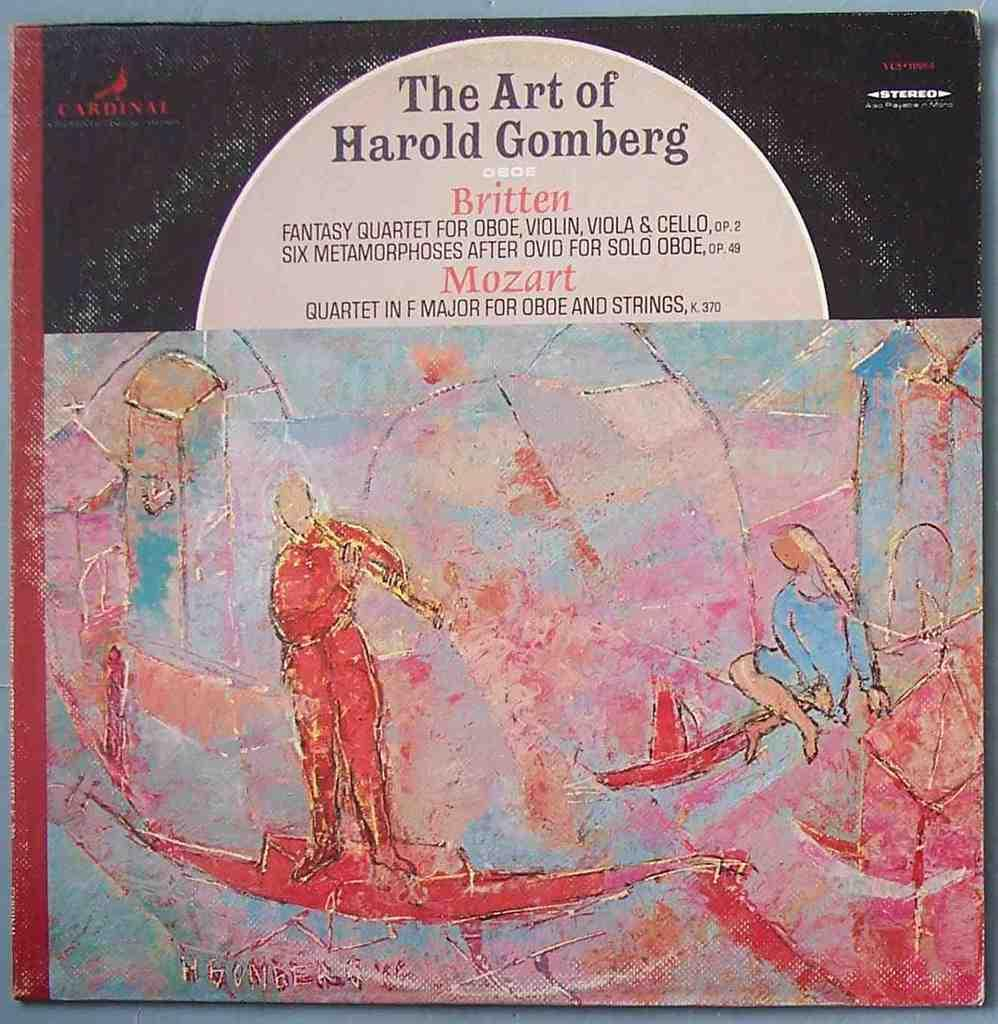Provide a one-sentence caption for the provided image. A stereo recording includes works by Britten and Mozart. 